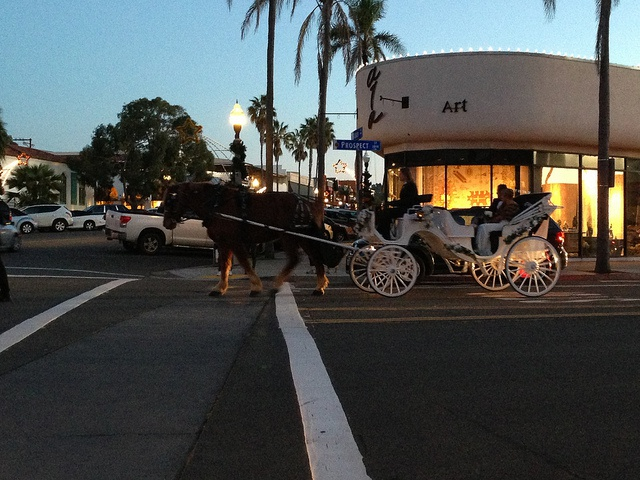Describe the objects in this image and their specific colors. I can see horse in lightblue, black, maroon, and gray tones, truck in lightblue, black, gray, and maroon tones, car in lightblue, black, and gray tones, people in lightblue, black, and gray tones, and people in lightblue, black, maroon, and gray tones in this image. 